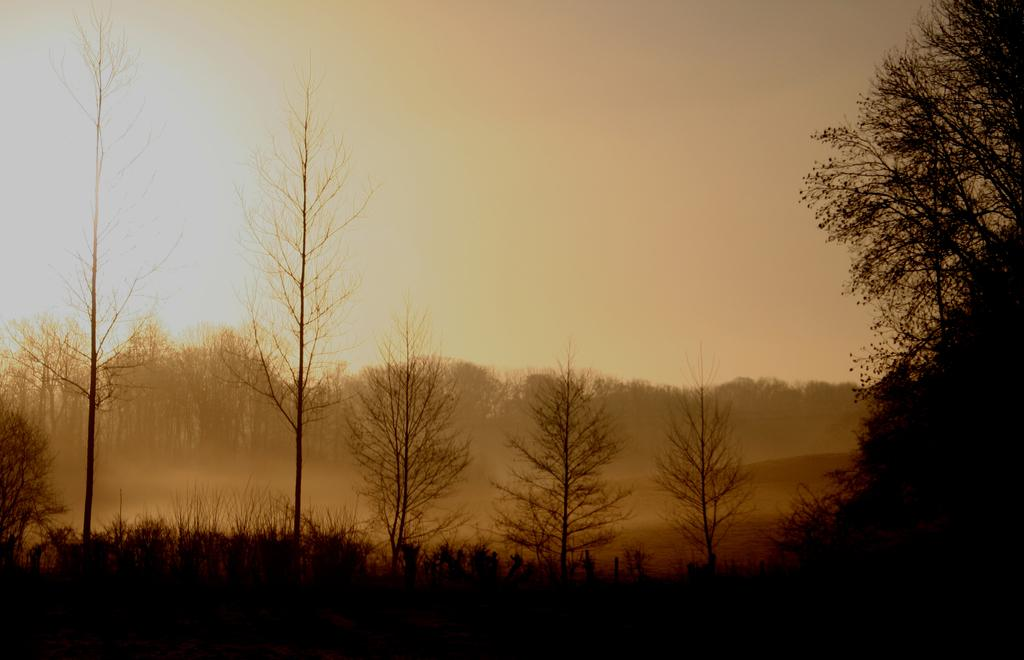What type of vegetation is present at the bottom of the image? There are trees at the bottom of the image. What part of the natural environment is visible at the top of the image? The sky is visible at the top of the image. What time of day is it in the image, and is there a horse present? The time of day cannot be determined from the image, and there is no horse present. 